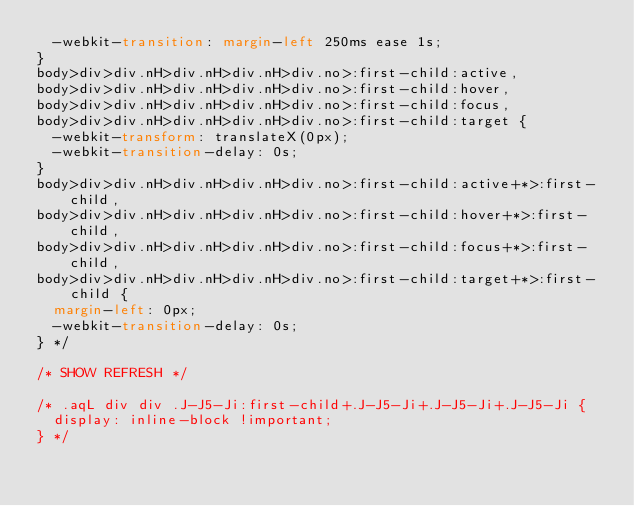<code> <loc_0><loc_0><loc_500><loc_500><_CSS_>  -webkit-transition: margin-left 250ms ease 1s;
}
body>div>div.nH>div.nH>div.nH>div.no>:first-child:active,
body>div>div.nH>div.nH>div.nH>div.no>:first-child:hover,
body>div>div.nH>div.nH>div.nH>div.no>:first-child:focus,
body>div>div.nH>div.nH>div.nH>div.no>:first-child:target {
  -webkit-transform: translateX(0px);
  -webkit-transition-delay: 0s;
}
body>div>div.nH>div.nH>div.nH>div.no>:first-child:active+*>:first-child,
body>div>div.nH>div.nH>div.nH>div.no>:first-child:hover+*>:first-child,
body>div>div.nH>div.nH>div.nH>div.no>:first-child:focus+*>:first-child,
body>div>div.nH>div.nH>div.nH>div.no>:first-child:target+*>:first-child {
  margin-left: 0px;
  -webkit-transition-delay: 0s;
} */

/* SHOW REFRESH */

/* .aqL div div .J-J5-Ji:first-child+.J-J5-Ji+.J-J5-Ji+.J-J5-Ji {
  display: inline-block !important;
} */</code> 